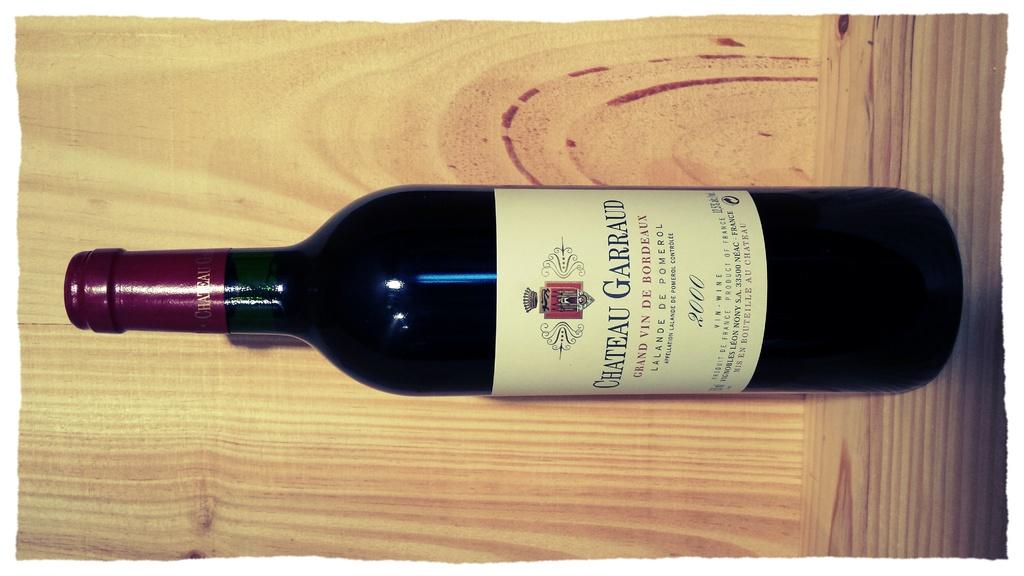What year was the wine made?
Offer a terse response. 2000. What brand of wine is this?
Keep it short and to the point. Chateau garraud. 